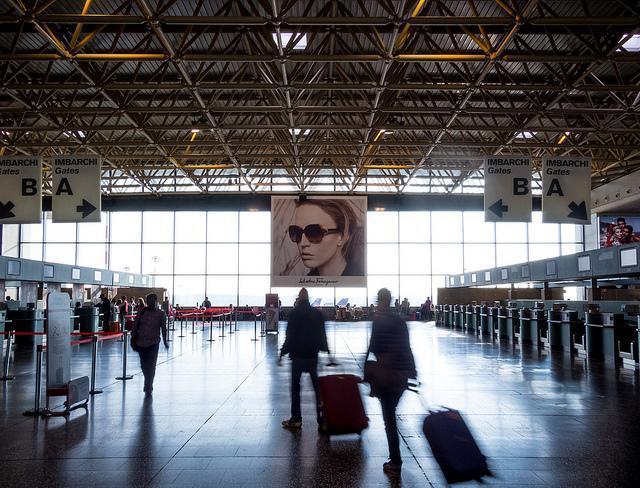How many people can you see?
Give a very brief answer. 4. How many suitcases can be seen?
Give a very brief answer. 2. 